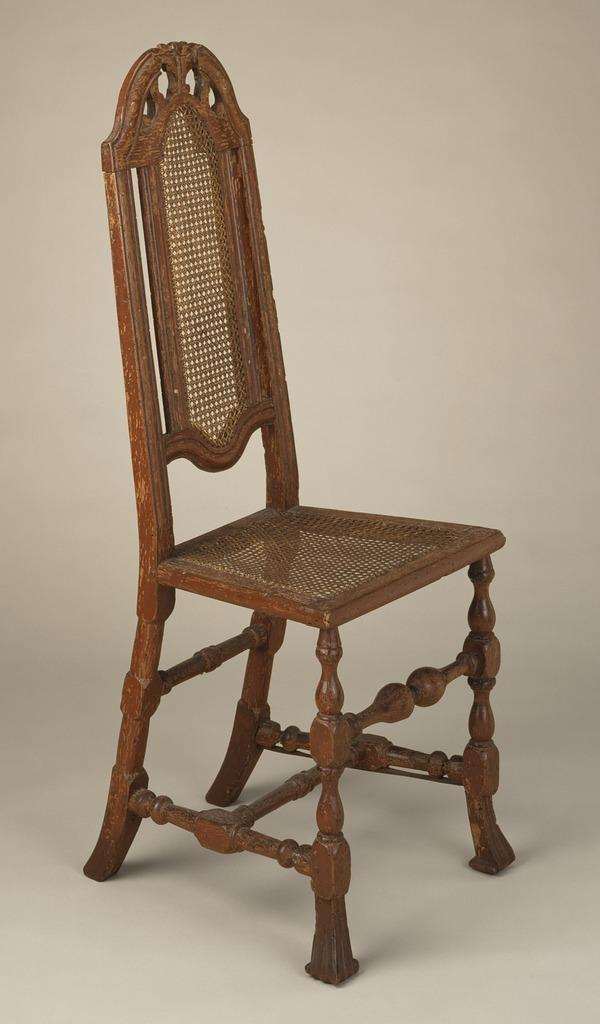What type of chair is in the image? There is a wooden chair in the image. How is the chair positioned in the image? The chair is arranged on a surface. What color is the background of the image? The background of the image is white in color. How many fish can be seen swimming in the powder in the image? There are no fish or powder present in the image; it features a wooden chair on a surface with a white background. 